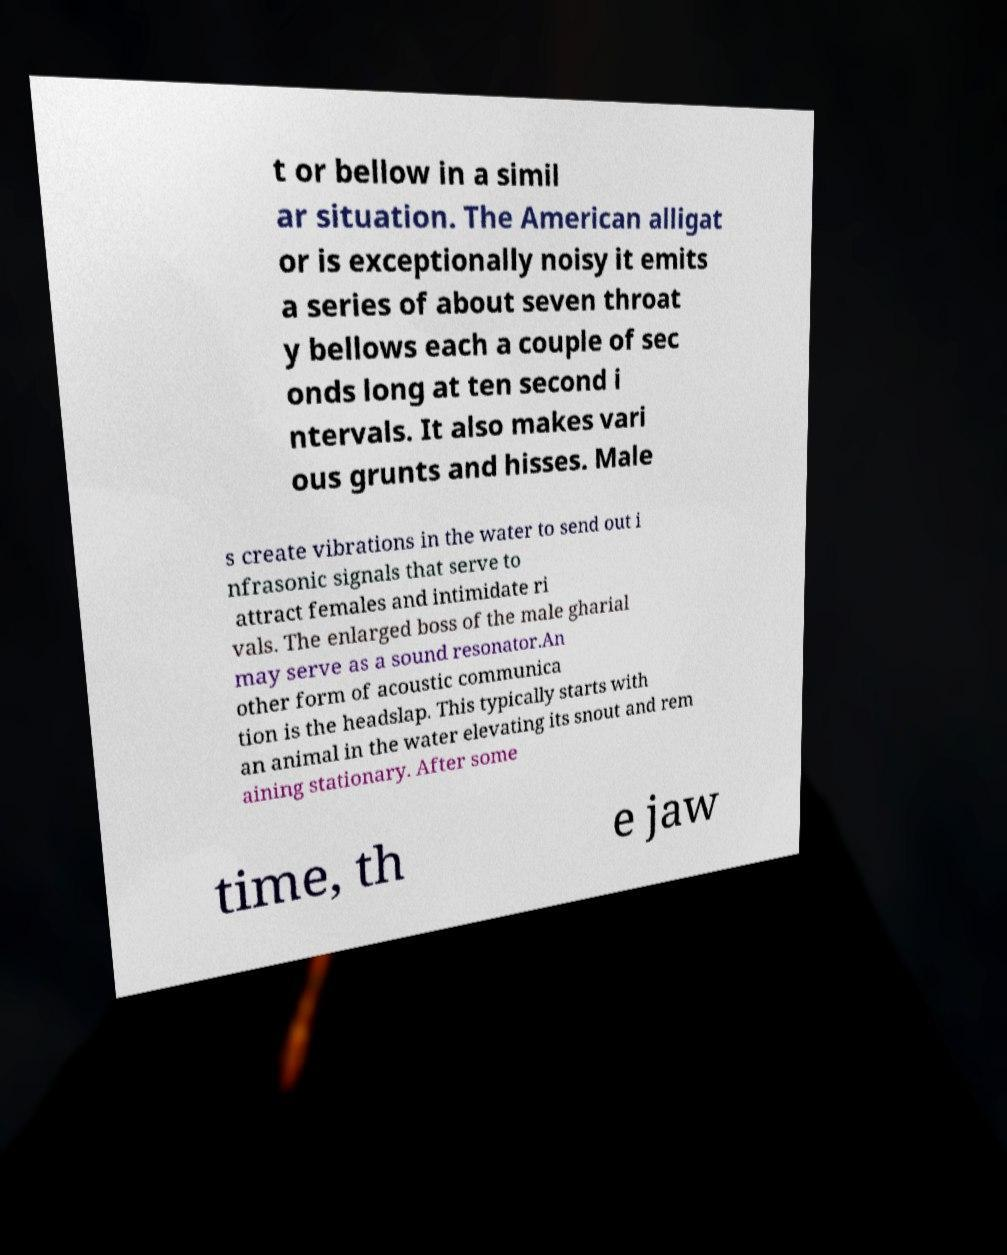Could you extract and type out the text from this image? t or bellow in a simil ar situation. The American alligat or is exceptionally noisy it emits a series of about seven throat y bellows each a couple of sec onds long at ten second i ntervals. It also makes vari ous grunts and hisses. Male s create vibrations in the water to send out i nfrasonic signals that serve to attract females and intimidate ri vals. The enlarged boss of the male gharial may serve as a sound resonator.An other form of acoustic communica tion is the headslap. This typically starts with an animal in the water elevating its snout and rem aining stationary. After some time, th e jaw 